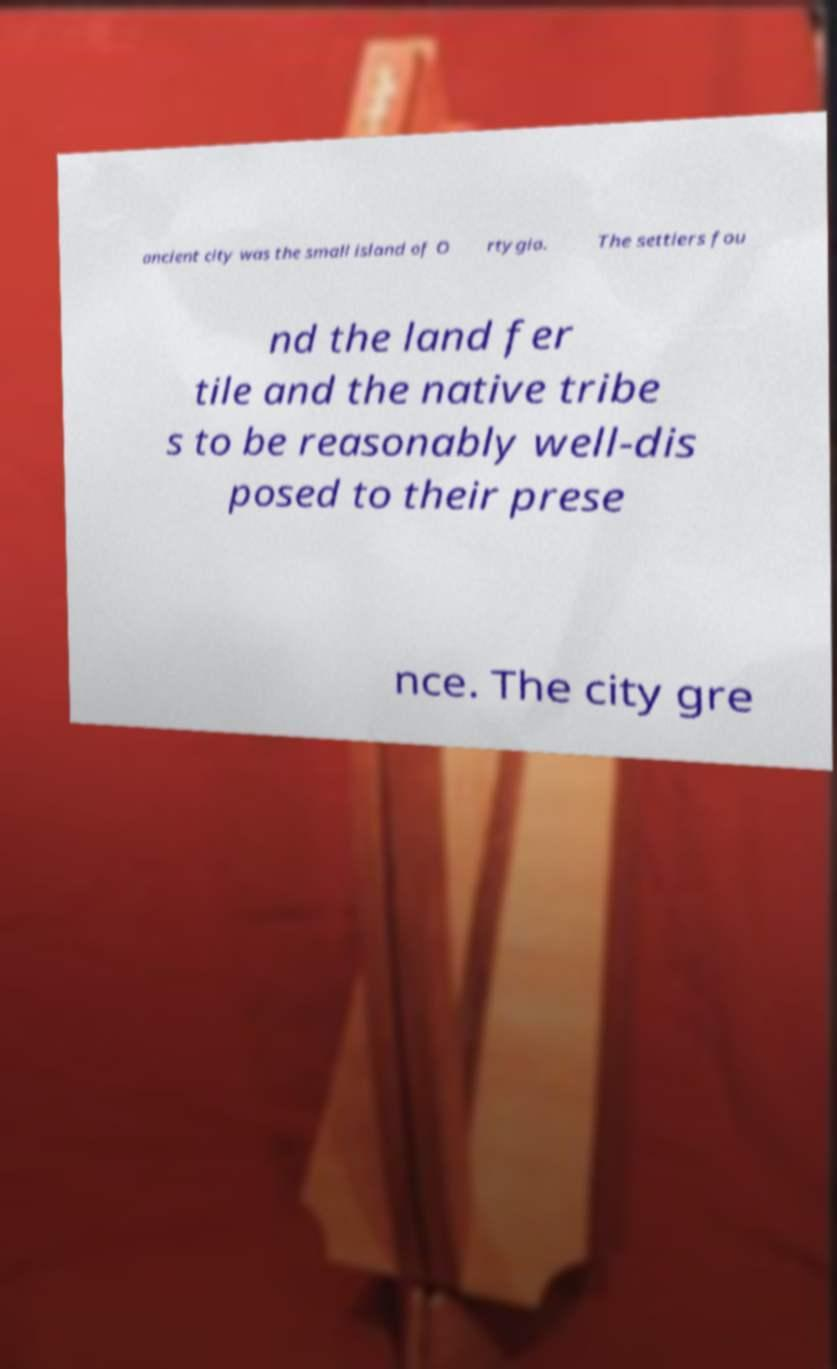Can you accurately transcribe the text from the provided image for me? ancient city was the small island of O rtygia. The settlers fou nd the land fer tile and the native tribe s to be reasonably well-dis posed to their prese nce. The city gre 